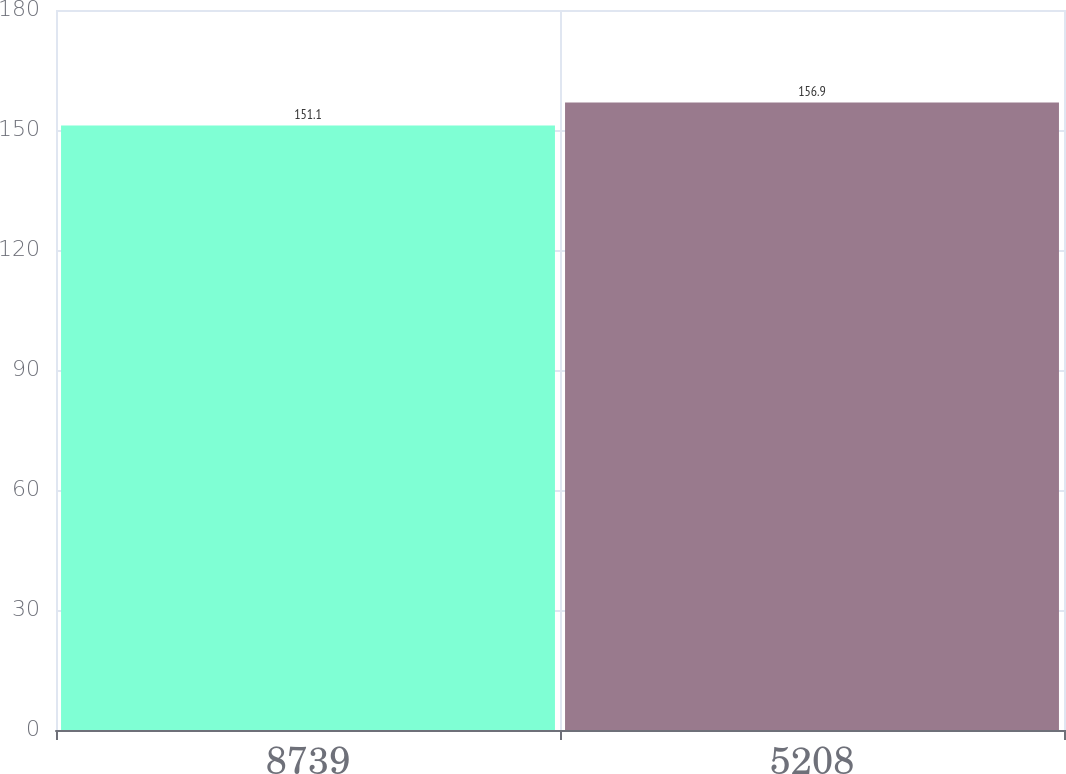Convert chart to OTSL. <chart><loc_0><loc_0><loc_500><loc_500><bar_chart><fcel>8739<fcel>5208<nl><fcel>151.1<fcel>156.9<nl></chart> 